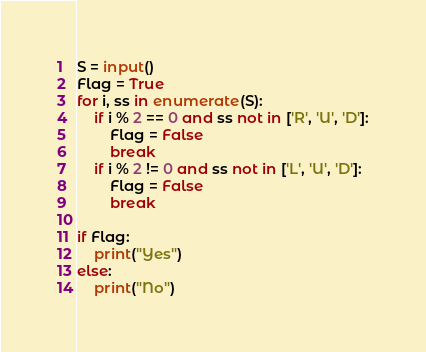Convert code to text. <code><loc_0><loc_0><loc_500><loc_500><_Python_>S = input()
Flag = True
for i, ss in enumerate(S):
    if i % 2 == 0 and ss not in ['R', 'U', 'D']:
        Flag = False
        break
    if i % 2 != 0 and ss not in ['L', 'U', 'D']:
        Flag = False
        break

if Flag:
    print("Yes")
else:
    print("No")
</code> 